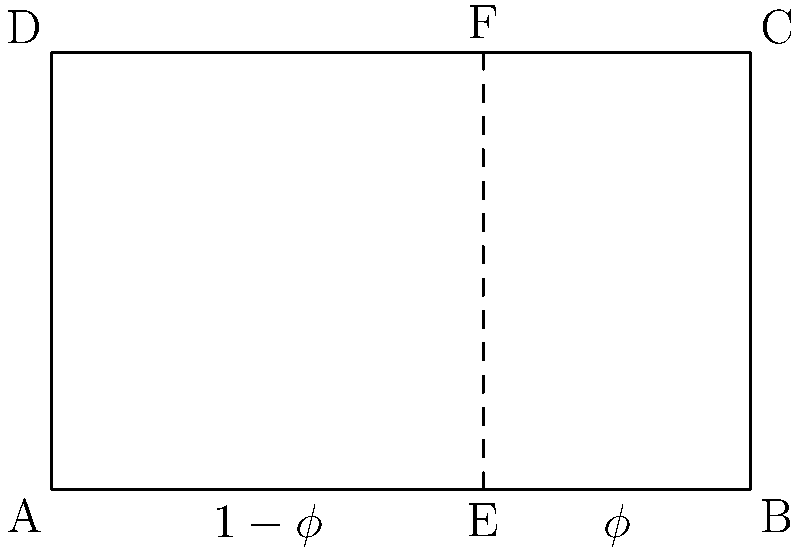In the design of a grand piano, the ratio of the length of the shorter side to the longer side is often close to the golden ratio. If the longer side of a rectangular piano lid measures 8 units and the total area of the lid is 40 square units, determine the length of the shorter side and verify if it approximates the golden ratio. (Use $\phi \approx 0.618$ for the golden ratio) Let's approach this step-by-step:

1) Let the shorter side be $x$ units.

2) Given information:
   - Longer side = 8 units
   - Area = 40 square units
   - Golden ratio $\phi \approx 0.618$

3) Using the area formula for a rectangle:
   $\text{Area} = \text{length} \times \text{width}$
   $40 = 8x$

4) Solve for $x$:
   $x = 40 \div 8 = 5$ units

5) So, the dimensions of the piano lid are 8 units by 5 units.

6) To check if this approximates the golden ratio:
   - Ratio of shorter to longer side = $5 \div 8 = 0.625$

7) Compare with the golden ratio:
   $0.625$ is very close to $0.618$

8) To further verify, we can check if the longer side divided by the shorter side is close to $\phi + 1 \approx 1.618$:
   $8 \div 5 = 1.6$, which is indeed very close to 1.618.
Answer: 5 units; Yes, it approximates the golden ratio. 